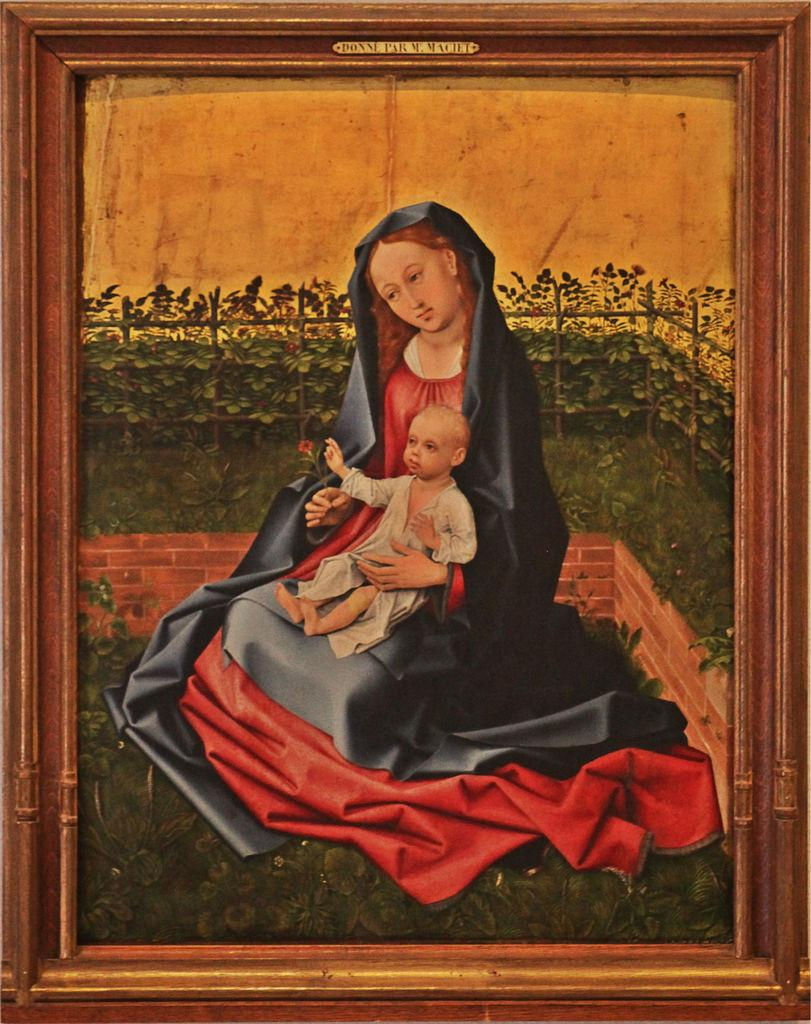Who is in the image? There is a woman in the image. What is the woman doing in the image? The woman is holding a child. What can be seen in the background of the image? There is a brick wall, a fence, and plants in the background of the image. What type of mine can be seen in the background of the image? There is no mine present in the image; it features a woman holding a child with a brick wall, fence, and plants in the background. 